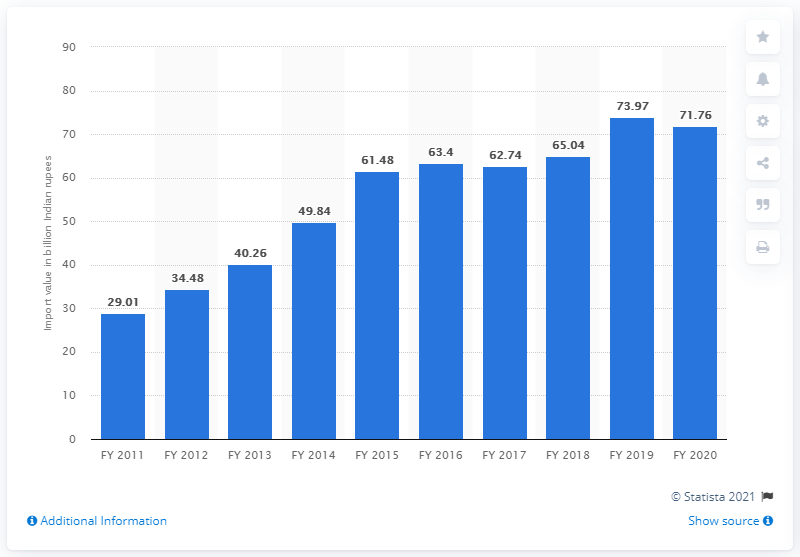Outline some significant characteristics in this image. In 2020, India imported a total of 71.76 million Indian rupees. The import value of leather in the previous financial year was 73.97. 